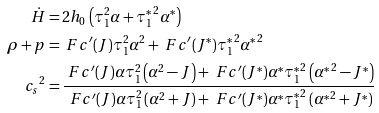Convert formula to latex. <formula><loc_0><loc_0><loc_500><loc_500>\dot { H } & = 2 h _ { 0 } \left ( \tau _ { 1 } ^ { 2 } \alpha + { \tau _ { 1 } ^ { * } } ^ { 2 } \alpha ^ { * } \right ) \\ \rho + p & = \ F c ^ { \prime } ( J ) \tau _ { 1 } ^ { 2 } \alpha ^ { 2 } + \ F c ^ { \prime } ( { J ^ { * } } ) { \tau _ { 1 } ^ { * } } ^ { 2 } { \alpha ^ { * } } ^ { 2 } \\ { c _ { s } } ^ { 2 } & = \frac { \ F c ^ { \prime } ( J ) \alpha \tau _ { 1 } ^ { 2 } \left ( \alpha ^ { 2 } - J \right ) + \ F c ^ { \prime } ( { J ^ { * } } ) \alpha ^ { * } { \tau _ { 1 } ^ { * } } ^ { 2 } \left ( { \alpha ^ { * } } ^ { 2 } - { J ^ { * } } \right ) } { \ F c ^ { \prime } ( J ) \alpha \tau _ { 1 } ^ { 2 } \left ( \alpha ^ { 2 } + J \right ) + \ F c ^ { \prime } ( { J ^ { * } } ) \alpha ^ { * } { \tau _ { 1 } ^ { * } } ^ { 2 } \left ( { \alpha ^ { * } } ^ { 2 } + { J ^ { * } } \right ) }</formula> 